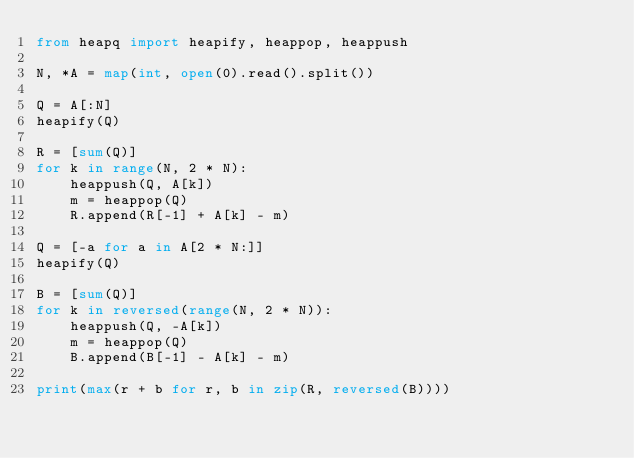<code> <loc_0><loc_0><loc_500><loc_500><_Python_>from heapq import heapify, heappop, heappush

N, *A = map(int, open(0).read().split())

Q = A[:N]
heapify(Q)

R = [sum(Q)]
for k in range(N, 2 * N):
    heappush(Q, A[k])
    m = heappop(Q)
    R.append(R[-1] + A[k] - m)

Q = [-a for a in A[2 * N:]]
heapify(Q)

B = [sum(Q)]
for k in reversed(range(N, 2 * N)):
    heappush(Q, -A[k])
    m = heappop(Q)
    B.append(B[-1] - A[k] - m)

print(max(r + b for r, b in zip(R, reversed(B))))
</code> 